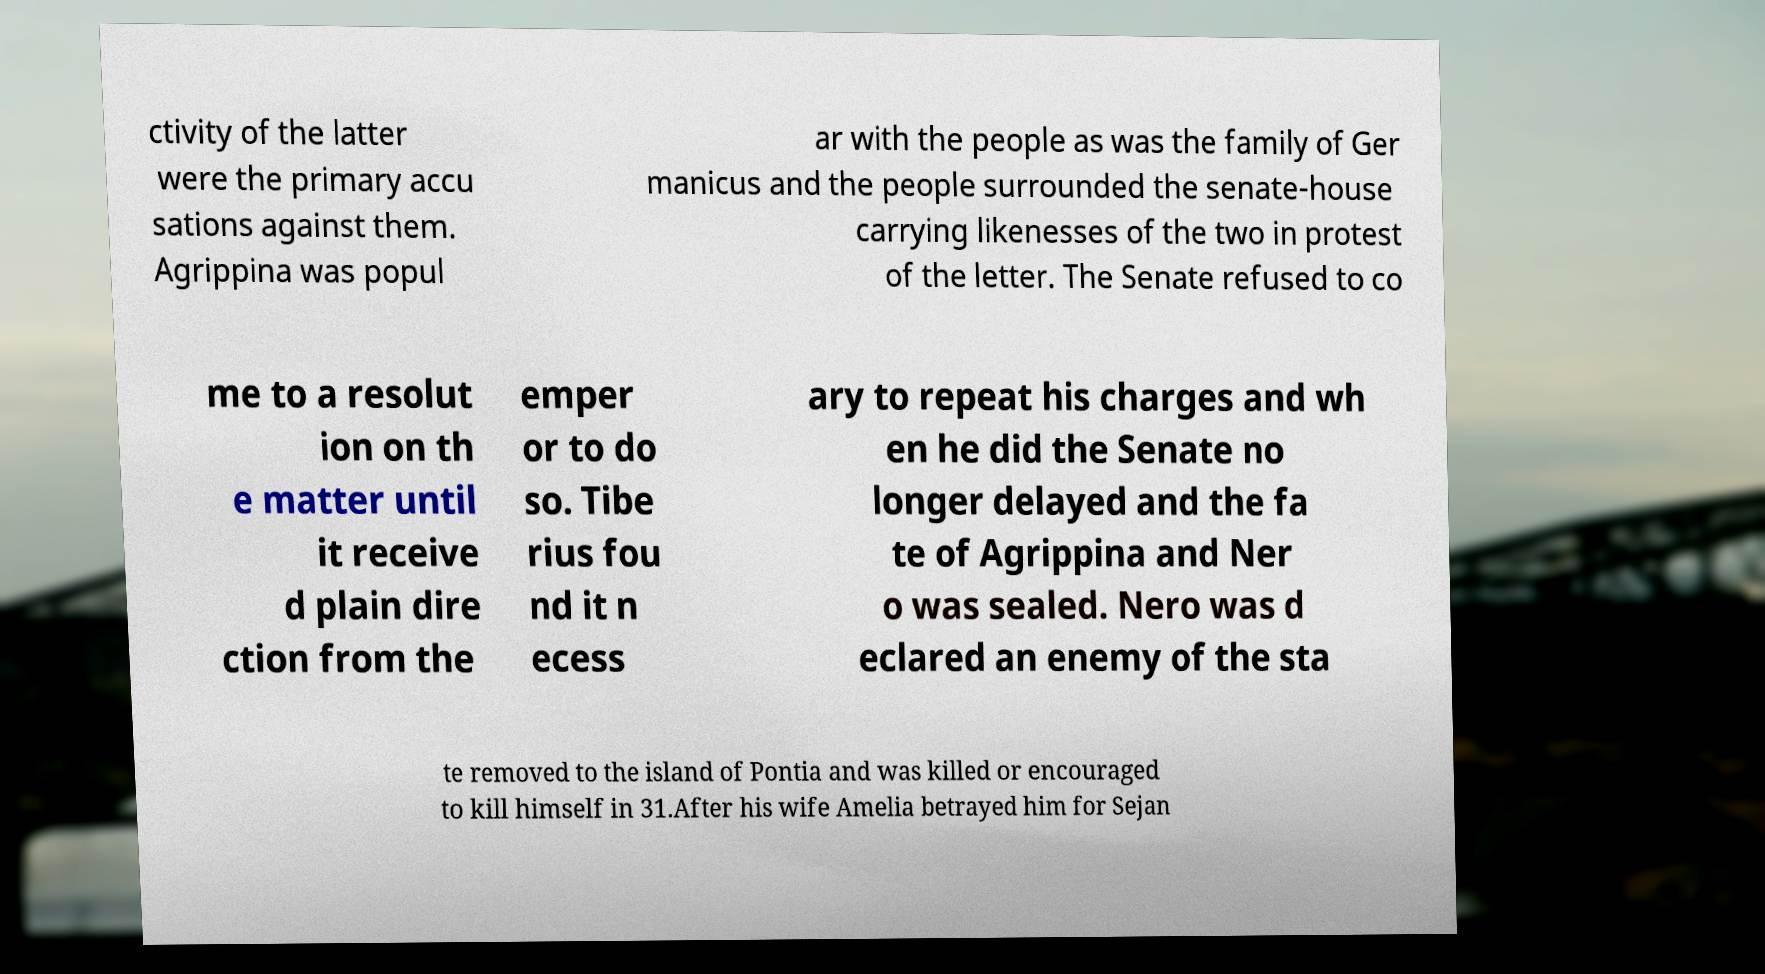What messages or text are displayed in this image? I need them in a readable, typed format. ctivity of the latter were the primary accu sations against them. Agrippina was popul ar with the people as was the family of Ger manicus and the people surrounded the senate-house carrying likenesses of the two in protest of the letter. The Senate refused to co me to a resolut ion on th e matter until it receive d plain dire ction from the emper or to do so. Tibe rius fou nd it n ecess ary to repeat his charges and wh en he did the Senate no longer delayed and the fa te of Agrippina and Ner o was sealed. Nero was d eclared an enemy of the sta te removed to the island of Pontia and was killed or encouraged to kill himself in 31.After his wife Amelia betrayed him for Sejan 